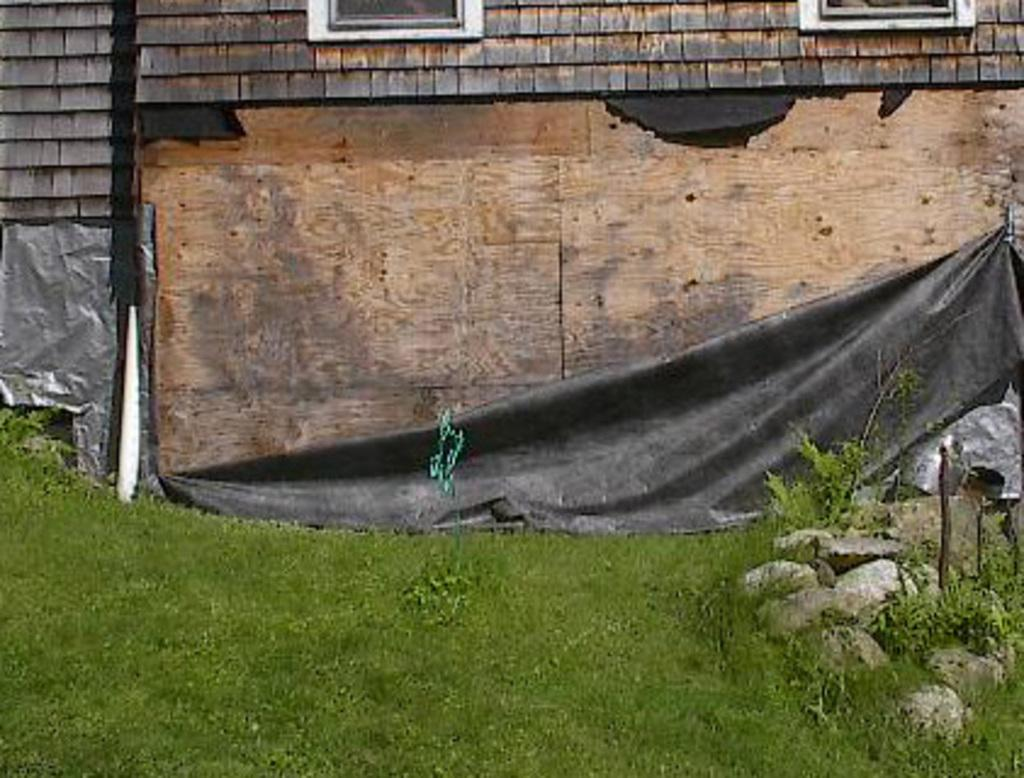What type of vegetation is present in the image? There is grass in the image. What can be seen on the right side of the image? There are stones on the right side of the image. What is visible in the background of the image? There is a wall in the background of the image. How many snakes are slithering through the grass in the image? There are no snakes present in the image; it only features grass, stones, and a wall. What year is depicted in the image? The image does not depict a specific year; it is a still image of grass, stones, and a wall. 